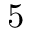<formula> <loc_0><loc_0><loc_500><loc_500>5</formula> 